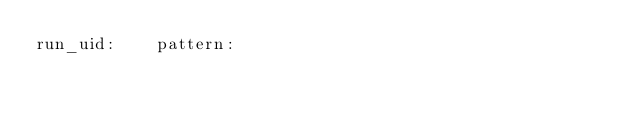Convert code to text. <code><loc_0><loc_0><loc_500><loc_500><_SQL_>run_uid:	pattern:

</code> 